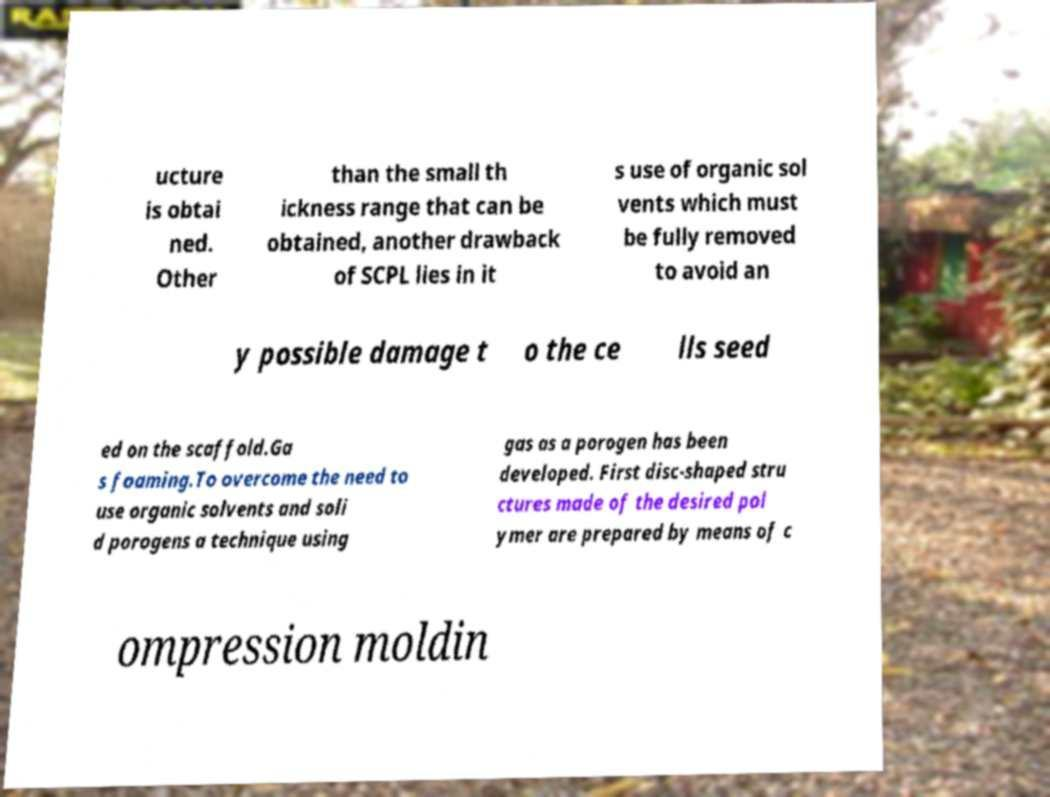Please identify and transcribe the text found in this image. ucture is obtai ned. Other than the small th ickness range that can be obtained, another drawback of SCPL lies in it s use of organic sol vents which must be fully removed to avoid an y possible damage t o the ce lls seed ed on the scaffold.Ga s foaming.To overcome the need to use organic solvents and soli d porogens a technique using gas as a porogen has been developed. First disc-shaped stru ctures made of the desired pol ymer are prepared by means of c ompression moldin 